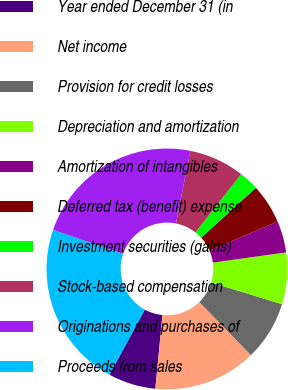Convert chart. <chart><loc_0><loc_0><loc_500><loc_500><pie_chart><fcel>Year ended December 31 (in<fcel>Net income<fcel>Provision for credit losses<fcel>Depreciation and amortization<fcel>Amortization of intangibles<fcel>Deferred tax (benefit) expense<fcel>Investment securities (gains)<fcel>Stock-based compensation<fcel>Originations and purchases of<fcel>Proceeds from sales<nl><fcel>6.38%<fcel>13.83%<fcel>7.98%<fcel>6.92%<fcel>4.26%<fcel>5.32%<fcel>2.66%<fcel>7.45%<fcel>22.87%<fcel>22.34%<nl></chart> 